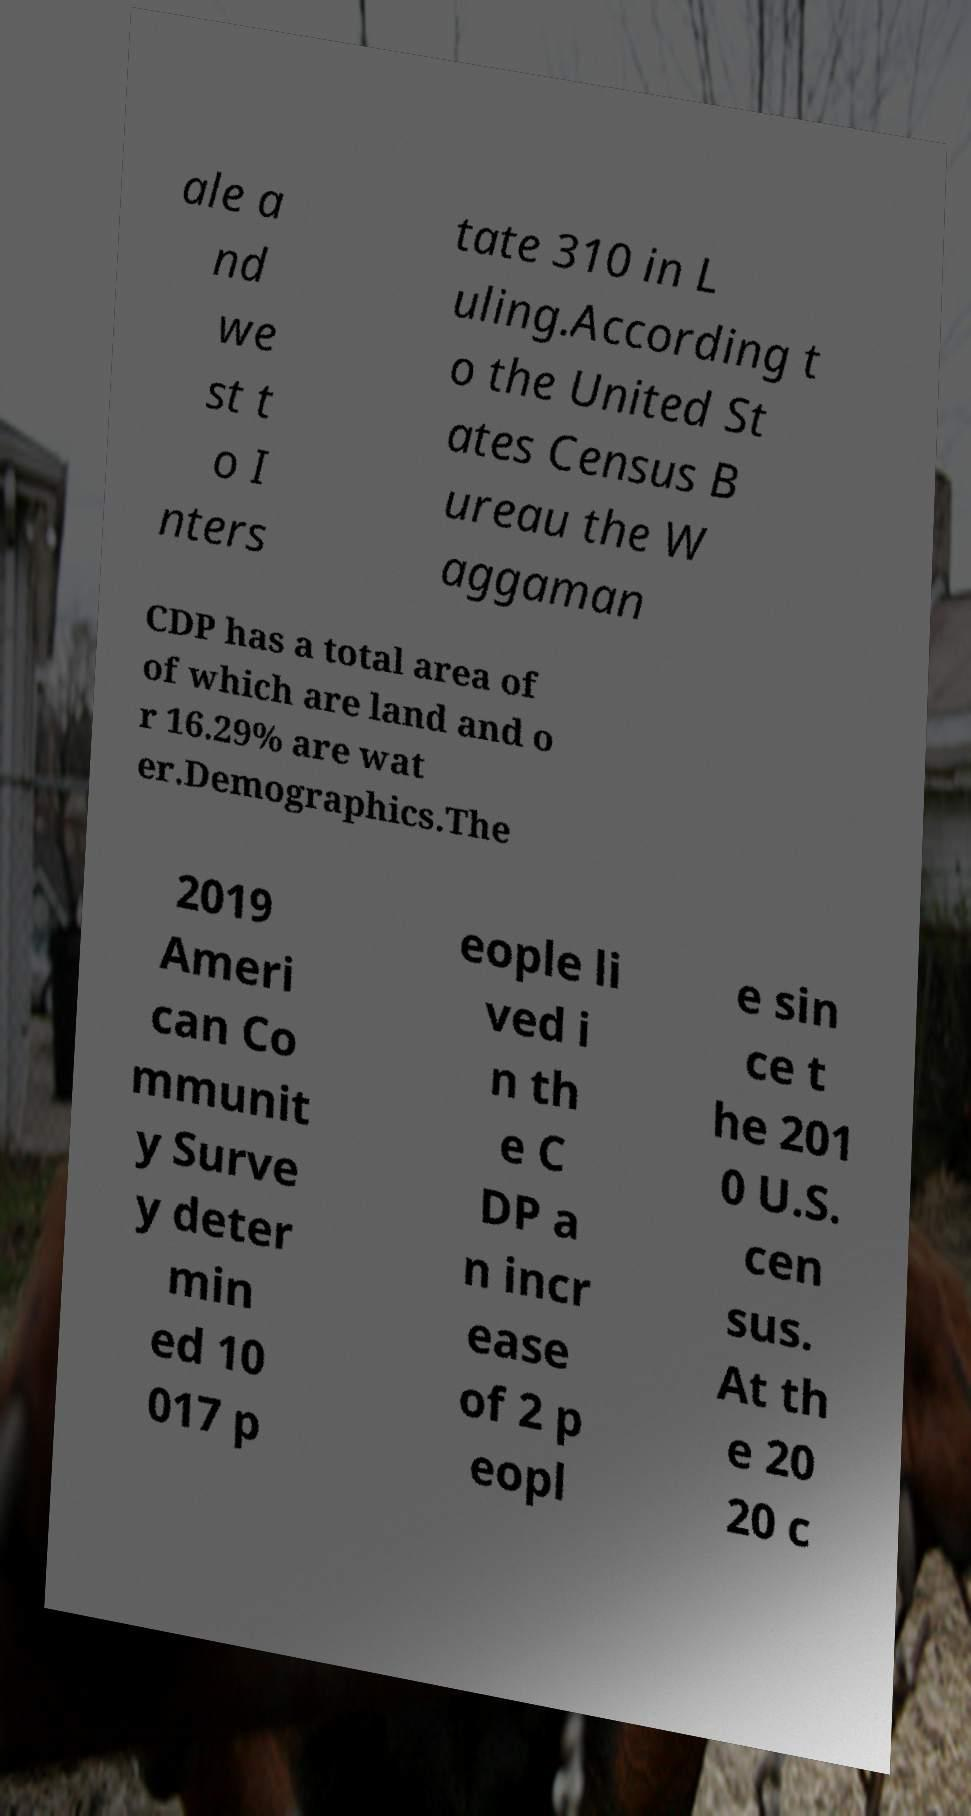Could you extract and type out the text from this image? ale a nd we st t o I nters tate 310 in L uling.According t o the United St ates Census B ureau the W aggaman CDP has a total area of of which are land and o r 16.29% are wat er.Demographics.The 2019 Ameri can Co mmunit y Surve y deter min ed 10 017 p eople li ved i n th e C DP a n incr ease of 2 p eopl e sin ce t he 201 0 U.S. cen sus. At th e 20 20 c 